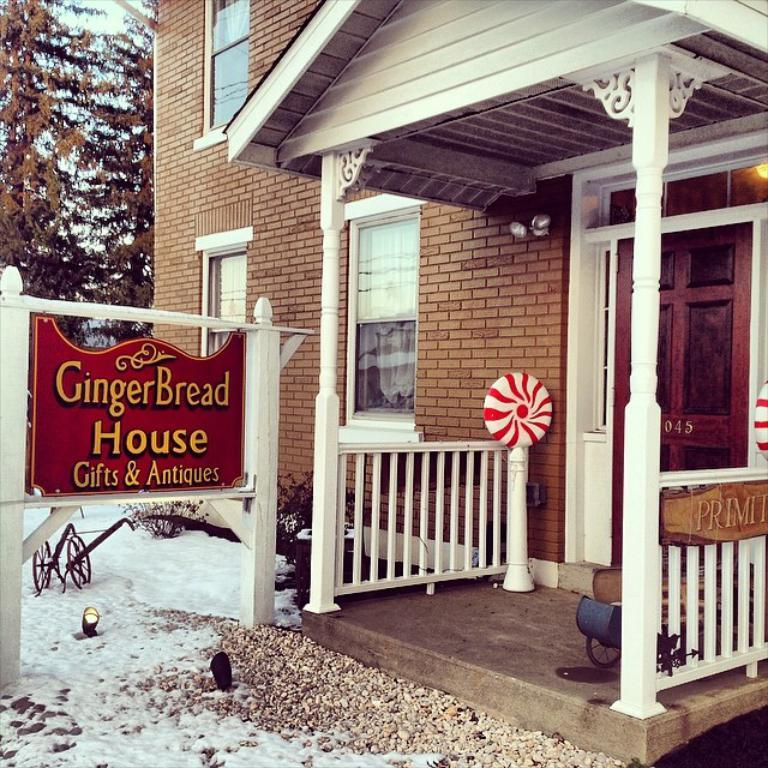What is the general appearance of the land in the image? The land in the image is covered with snow. What structure can be seen in the background of the image? There is a house in the background of the image. What object with text is visible in the image? There is a board with text on it in the image. What type of vegetation is present behind the board? Trees are present behind the board. What type of religious gathering is taking place in the image? There is no indication of a religious gathering in the image; it primarily features snow-covered land, a house, a board with text, and trees. 